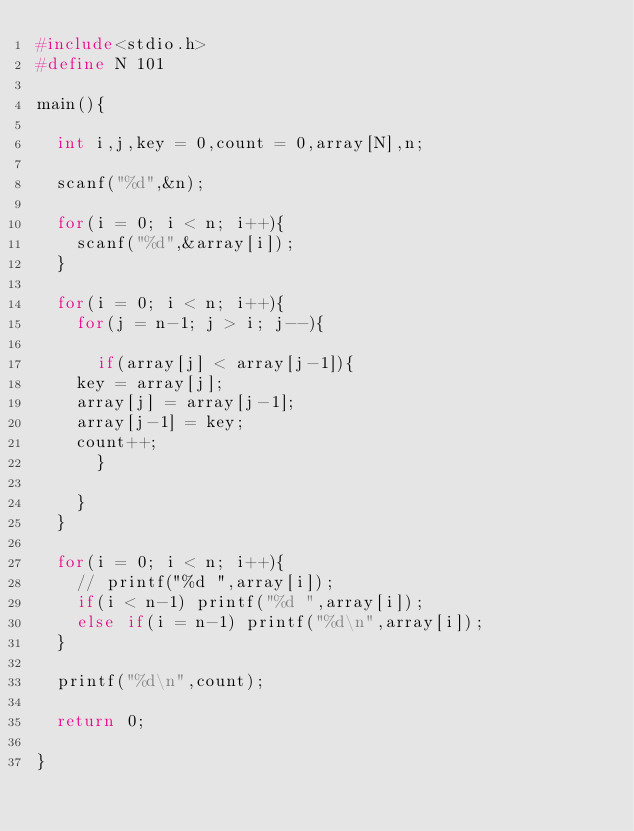<code> <loc_0><loc_0><loc_500><loc_500><_C_>#include<stdio.h>
#define N 101

main(){

  int i,j,key = 0,count = 0,array[N],n;

  scanf("%d",&n);

  for(i = 0; i < n; i++){
    scanf("%d",&array[i]);
  }

  for(i = 0; i < n; i++){
    for(j = n-1; j > i; j--){
      
      if(array[j] < array[j-1]){
	key = array[j];
	array[j] = array[j-1];
	array[j-1] = key;
	count++;
      }

    }
  }

  for(i = 0; i < n; i++){
    // printf("%d ",array[i]);
    if(i < n-1) printf("%d ",array[i]);
    else if(i = n-1) printf("%d\n",array[i]);
  }

  printf("%d\n",count);

  return 0;

}</code> 